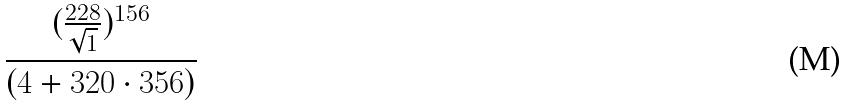Convert formula to latex. <formula><loc_0><loc_0><loc_500><loc_500>\frac { ( \frac { 2 2 8 } { \sqrt { 1 } } ) ^ { 1 5 6 } } { ( 4 + 3 2 0 \cdot 3 5 6 ) }</formula> 